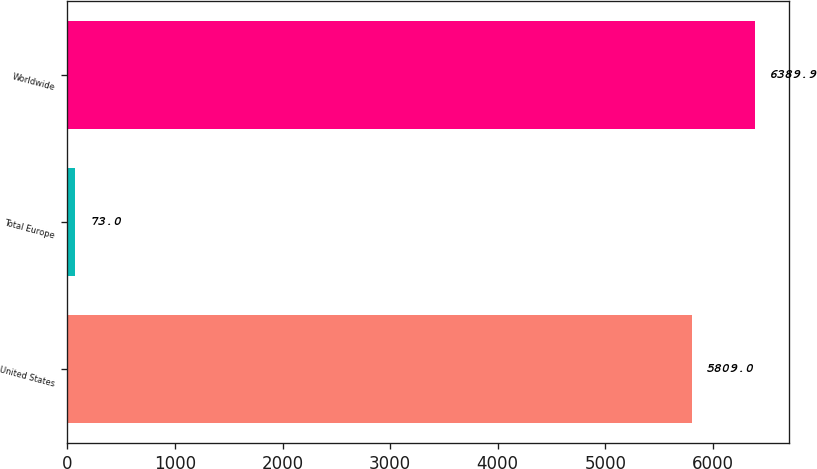Convert chart to OTSL. <chart><loc_0><loc_0><loc_500><loc_500><bar_chart><fcel>United States<fcel>Total Europe<fcel>Worldwide<nl><fcel>5809<fcel>73<fcel>6389.9<nl></chart> 